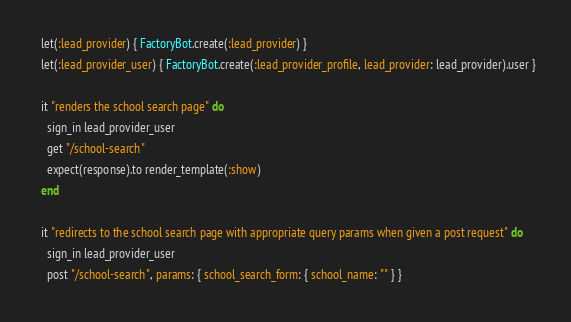<code> <loc_0><loc_0><loc_500><loc_500><_Ruby_>  let(:lead_provider) { FactoryBot.create(:lead_provider) }
  let(:lead_provider_user) { FactoryBot.create(:lead_provider_profile, lead_provider: lead_provider).user }

  it "renders the school search page" do
    sign_in lead_provider_user
    get "/school-search"
    expect(response).to render_template(:show)
  end

  it "redirects to the school search page with appropriate query params when given a post request" do
    sign_in lead_provider_user
    post "/school-search", params: { school_search_form: { school_name: "" } }</code> 